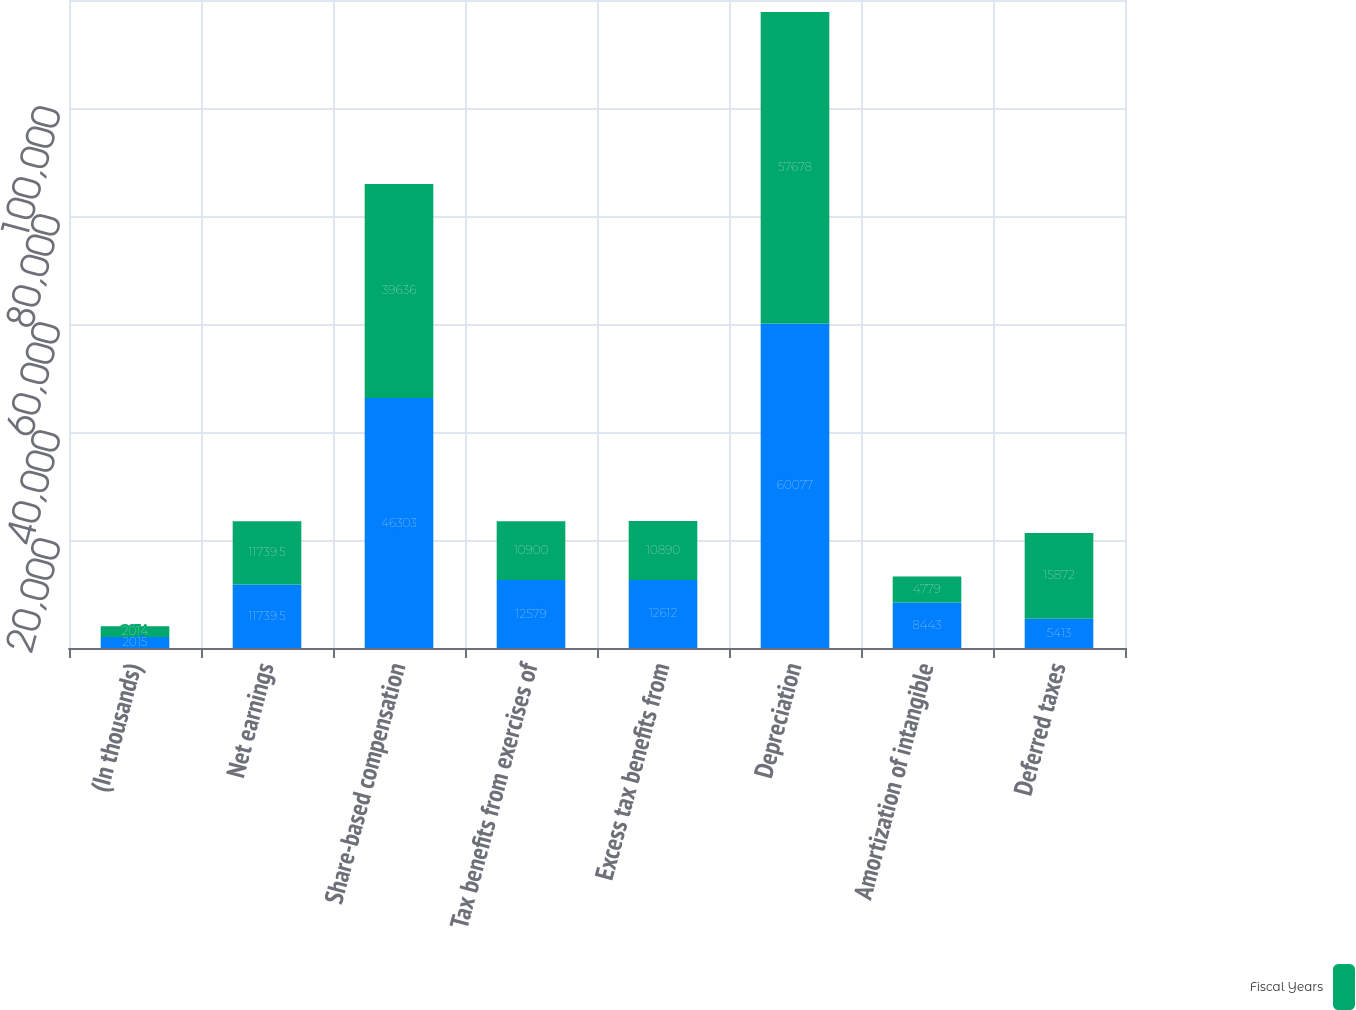Convert chart. <chart><loc_0><loc_0><loc_500><loc_500><stacked_bar_chart><ecel><fcel>(In thousands)<fcel>Net earnings<fcel>Share-based compensation<fcel>Tax benefits from exercises of<fcel>Excess tax benefits from<fcel>Depreciation<fcel>Amortization of intangible<fcel>Deferred taxes<nl><fcel>nan<fcel>2015<fcel>11739.5<fcel>46303<fcel>12579<fcel>12612<fcel>60077<fcel>8443<fcel>5413<nl><fcel>Fiscal Years<fcel>2014<fcel>11739.5<fcel>39636<fcel>10900<fcel>10890<fcel>57678<fcel>4779<fcel>15872<nl></chart> 